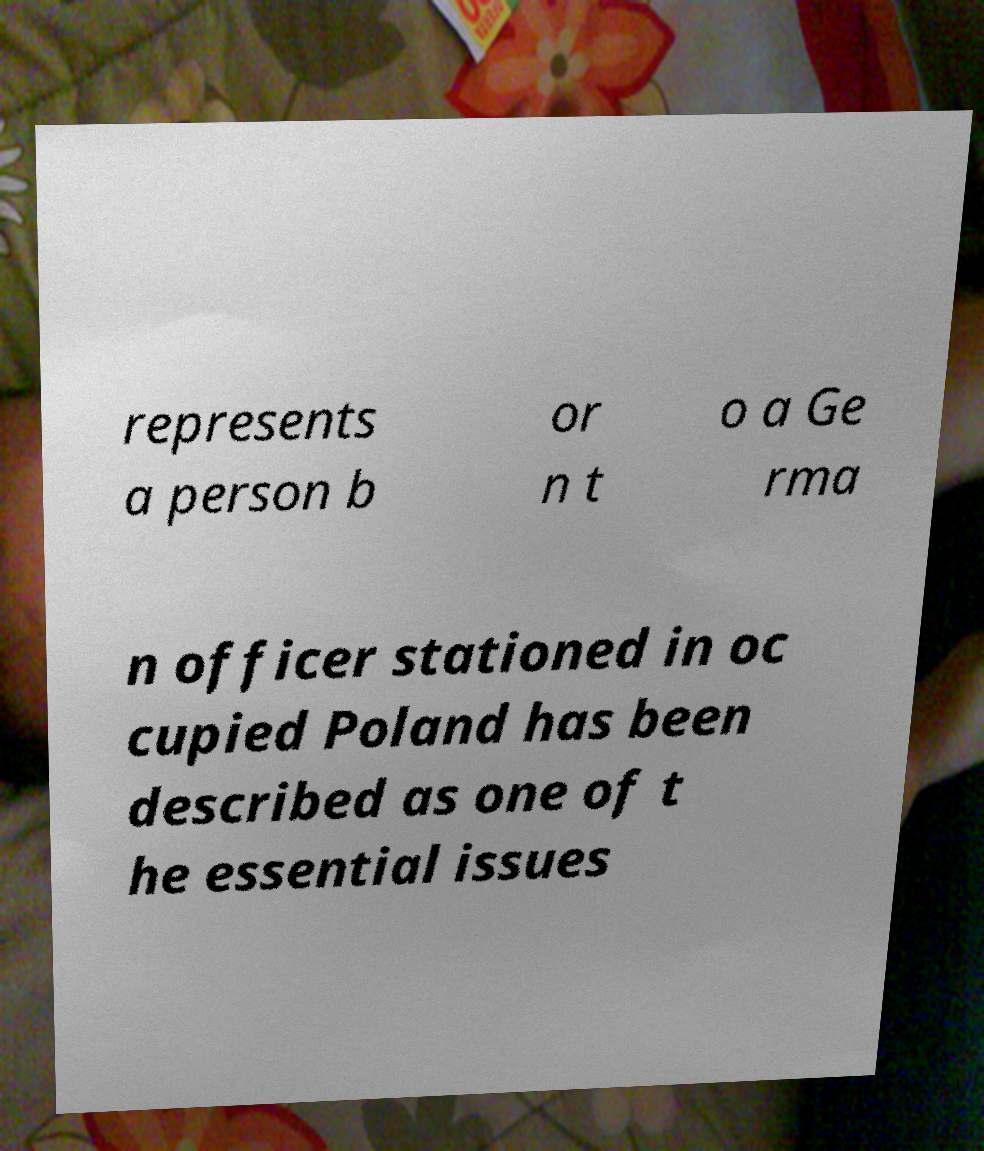Can you read and provide the text displayed in the image?This photo seems to have some interesting text. Can you extract and type it out for me? represents a person b or n t o a Ge rma n officer stationed in oc cupied Poland has been described as one of t he essential issues 